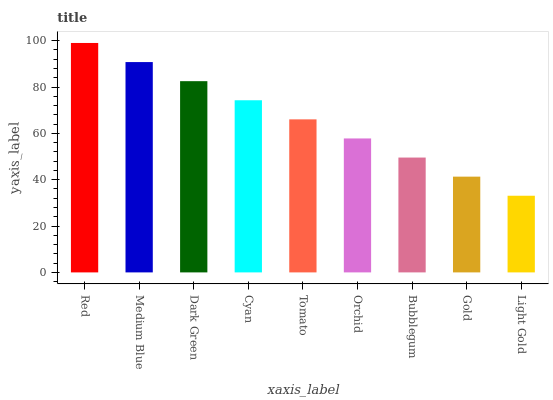Is Light Gold the minimum?
Answer yes or no. Yes. Is Red the maximum?
Answer yes or no. Yes. Is Medium Blue the minimum?
Answer yes or no. No. Is Medium Blue the maximum?
Answer yes or no. No. Is Red greater than Medium Blue?
Answer yes or no. Yes. Is Medium Blue less than Red?
Answer yes or no. Yes. Is Medium Blue greater than Red?
Answer yes or no. No. Is Red less than Medium Blue?
Answer yes or no. No. Is Tomato the high median?
Answer yes or no. Yes. Is Tomato the low median?
Answer yes or no. Yes. Is Light Gold the high median?
Answer yes or no. No. Is Orchid the low median?
Answer yes or no. No. 